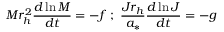Convert formula to latex. <formula><loc_0><loc_0><loc_500><loc_500>M r _ { h } ^ { 2 } { \frac { d \ln M } { d t } } = - f \, ; \, { \frac { J r _ { h } } { a _ { * } } } { \frac { d \ln J } { d t } } = - g</formula> 